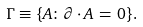Convert formula to latex. <formula><loc_0><loc_0><loc_500><loc_500>\Gamma \equiv \{ A \colon \partial \cdot A \, = \, 0 \} .</formula> 